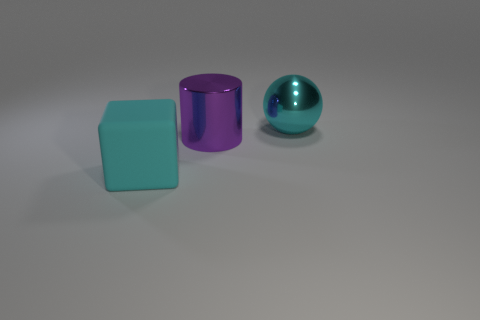Is the large sphere the same color as the rubber block?
Provide a succinct answer. Yes. How many objects are either large objects in front of the large cyan sphere or tiny blue rubber spheres?
Provide a short and direct response. 2. Does the shiny object left of the large ball have the same size as the cyan object that is left of the large ball?
Provide a succinct answer. Yes. Is there any other thing that is made of the same material as the large cyan cube?
Keep it short and to the point. No. How many objects are either cyan objects on the left side of the cyan sphere or things that are on the left side of the purple shiny object?
Offer a terse response. 1. Is the material of the big block the same as the cyan object behind the big cyan matte object?
Give a very brief answer. No. The thing that is on the left side of the large cyan metallic ball and behind the cyan cube has what shape?
Offer a terse response. Cylinder. What number of other things are there of the same color as the sphere?
Give a very brief answer. 1. The purple metallic object has what shape?
Offer a terse response. Cylinder. There is a shiny object that is on the left side of the large cyan object that is right of the cube; what color is it?
Your answer should be compact. Purple. 